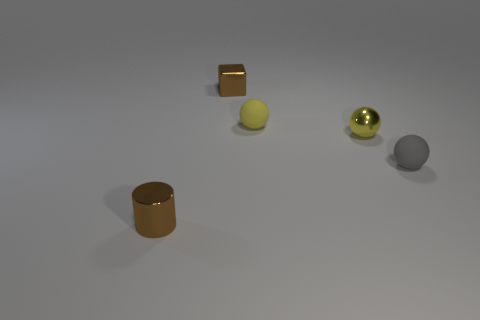What number of large objects are either yellow metallic things or yellow rubber balls?
Keep it short and to the point. 0. Is the number of small brown metallic balls greater than the number of tiny metal cylinders?
Your response must be concise. No. How many cylinders are on the left side of the thing left of the tiny brown thing on the right side of the brown metallic cylinder?
Provide a short and direct response. 0. What is the shape of the yellow matte object?
Your response must be concise. Sphere. How many other things are the same material as the brown cylinder?
Give a very brief answer. 2. There is a brown object that is behind the metallic cylinder; what is its shape?
Provide a succinct answer. Cube. There is a small metal thing that is in front of the tiny rubber thing to the right of the yellow matte sphere; what color is it?
Keep it short and to the point. Brown. Does the tiny matte thing to the left of the small shiny sphere have the same shape as the tiny metal thing that is on the right side of the small block?
Provide a short and direct response. Yes. What is the shape of the rubber thing that is the same size as the gray rubber ball?
Your answer should be compact. Sphere. There is a sphere that is made of the same material as the cube; what color is it?
Offer a terse response. Yellow. 